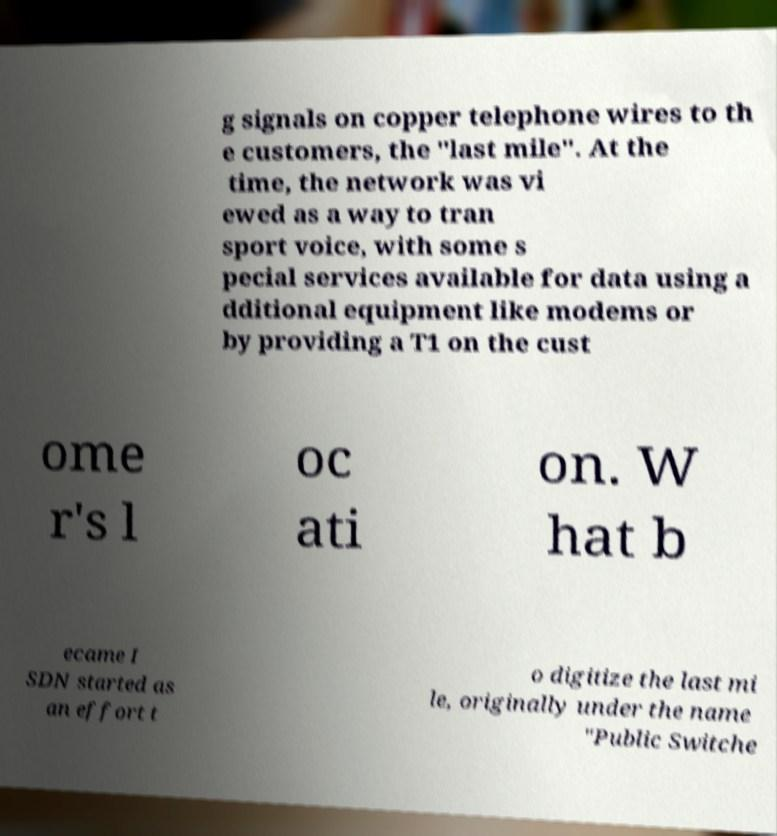What messages or text are displayed in this image? I need them in a readable, typed format. g signals on copper telephone wires to th e customers, the "last mile". At the time, the network was vi ewed as a way to tran sport voice, with some s pecial services available for data using a dditional equipment like modems or by providing a T1 on the cust ome r's l oc ati on. W hat b ecame I SDN started as an effort t o digitize the last mi le, originally under the name "Public Switche 